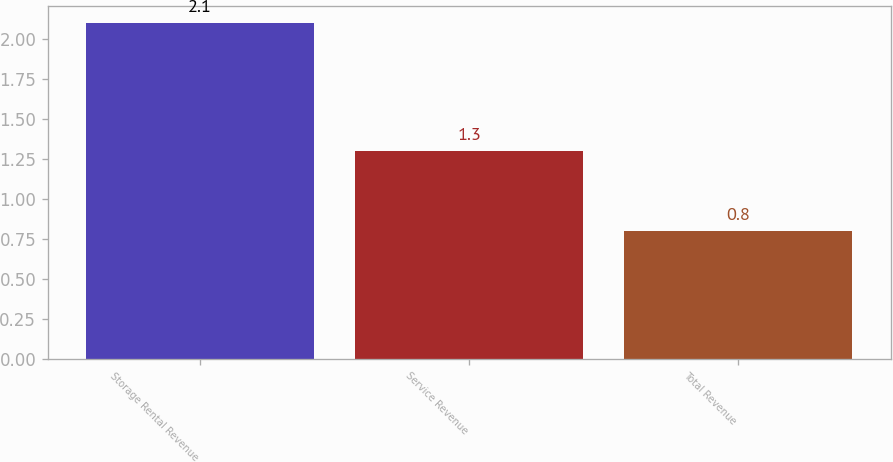<chart> <loc_0><loc_0><loc_500><loc_500><bar_chart><fcel>Storage Rental Revenue<fcel>Service Revenue<fcel>Total Revenue<nl><fcel>2.1<fcel>1.3<fcel>0.8<nl></chart> 